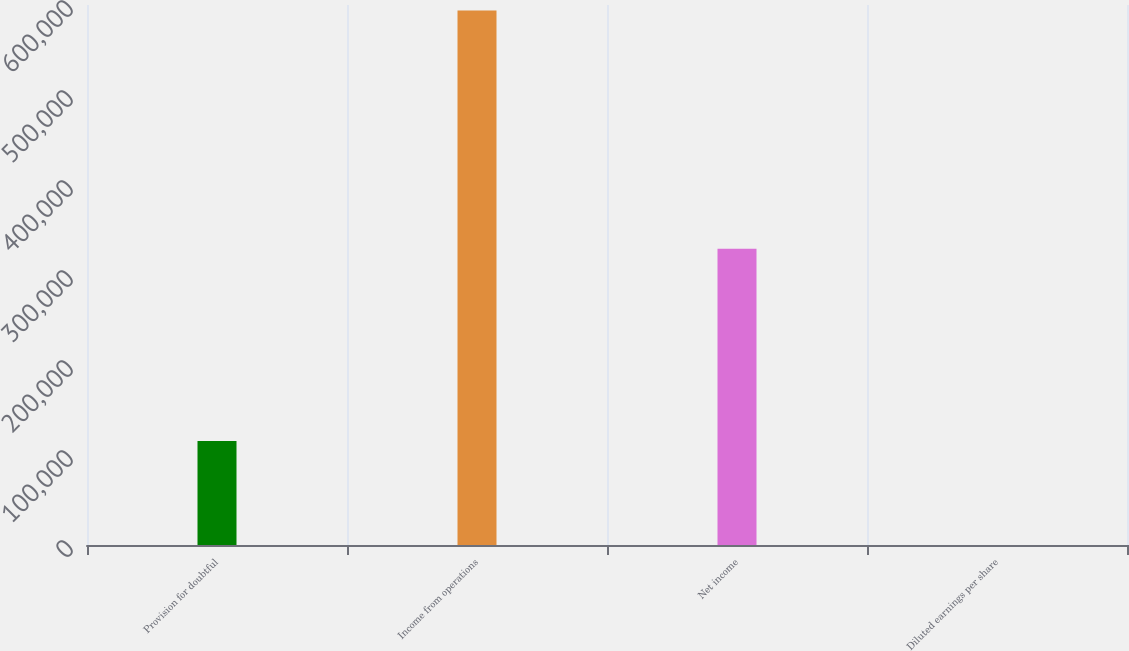<chart> <loc_0><loc_0><loc_500><loc_500><bar_chart><fcel>Provision for doubtful<fcel>Income from operations<fcel>Net income<fcel>Diluted earnings per share<nl><fcel>115642<fcel>593999<fcel>329070<fcel>0.24<nl></chart> 